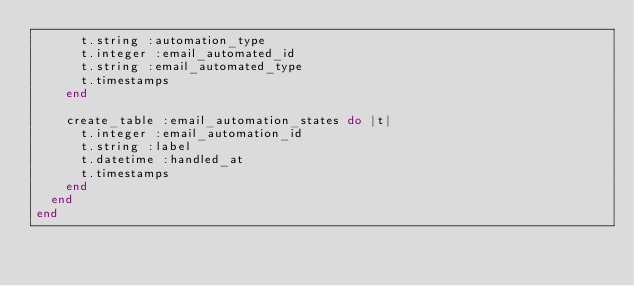Convert code to text. <code><loc_0><loc_0><loc_500><loc_500><_Ruby_>      t.string :automation_type
      t.integer :email_automated_id
      t.string :email_automated_type
      t.timestamps
    end

    create_table :email_automation_states do |t|
      t.integer :email_automation_id
      t.string :label
      t.datetime :handled_at
      t.timestamps
    end
  end
end
</code> 